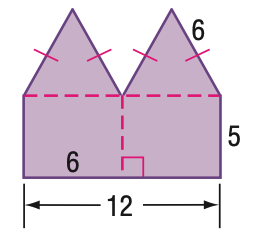Answer the mathemtical geometry problem and directly provide the correct option letter.
Question: Find the area of the figure. Round to the nearest tenth.
Choices: A: 75.6 B: 91.2 C: 96 D: 101.6 B 